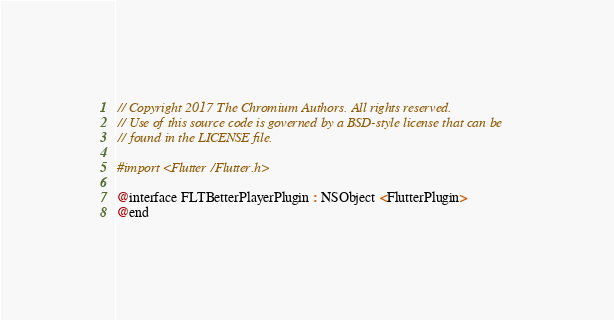Convert code to text. <code><loc_0><loc_0><loc_500><loc_500><_C_>// Copyright 2017 The Chromium Authors. All rights reserved.
// Use of this source code is governed by a BSD-style license that can be
// found in the LICENSE file.

#import <Flutter/Flutter.h>

@interface FLTBetterPlayerPlugin : NSObject <FlutterPlugin>
@end
</code> 